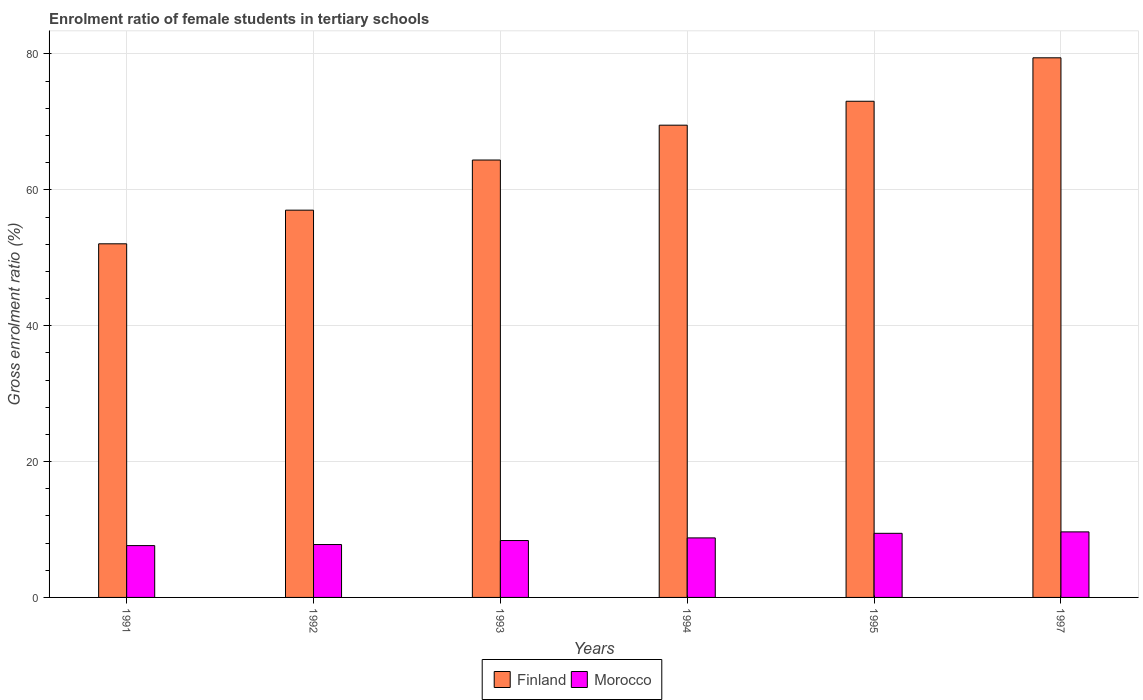How many groups of bars are there?
Give a very brief answer. 6. Are the number of bars per tick equal to the number of legend labels?
Keep it short and to the point. Yes. How many bars are there on the 3rd tick from the left?
Give a very brief answer. 2. What is the label of the 1st group of bars from the left?
Your answer should be compact. 1991. In how many cases, is the number of bars for a given year not equal to the number of legend labels?
Provide a succinct answer. 0. What is the enrolment ratio of female students in tertiary schools in Finland in 1994?
Make the answer very short. 69.52. Across all years, what is the maximum enrolment ratio of female students in tertiary schools in Finland?
Ensure brevity in your answer.  79.43. Across all years, what is the minimum enrolment ratio of female students in tertiary schools in Finland?
Offer a very short reply. 52.05. What is the total enrolment ratio of female students in tertiary schools in Morocco in the graph?
Make the answer very short. 51.64. What is the difference between the enrolment ratio of female students in tertiary schools in Finland in 1992 and that in 1995?
Your answer should be very brief. -16.03. What is the difference between the enrolment ratio of female students in tertiary schools in Finland in 1993 and the enrolment ratio of female students in tertiary schools in Morocco in 1995?
Make the answer very short. 54.95. What is the average enrolment ratio of female students in tertiary schools in Morocco per year?
Give a very brief answer. 8.61. In the year 1994, what is the difference between the enrolment ratio of female students in tertiary schools in Finland and enrolment ratio of female students in tertiary schools in Morocco?
Give a very brief answer. 60.75. What is the ratio of the enrolment ratio of female students in tertiary schools in Morocco in 1994 to that in 1997?
Keep it short and to the point. 0.91. Is the enrolment ratio of female students in tertiary schools in Finland in 1992 less than that in 1994?
Provide a short and direct response. Yes. What is the difference between the highest and the second highest enrolment ratio of female students in tertiary schools in Morocco?
Offer a very short reply. 0.21. What is the difference between the highest and the lowest enrolment ratio of female students in tertiary schools in Morocco?
Give a very brief answer. 2.02. Is the sum of the enrolment ratio of female students in tertiary schools in Finland in 1991 and 1993 greater than the maximum enrolment ratio of female students in tertiary schools in Morocco across all years?
Keep it short and to the point. Yes. What does the 1st bar from the left in 1995 represents?
Your response must be concise. Finland. What does the 1st bar from the right in 1993 represents?
Your response must be concise. Morocco. Are all the bars in the graph horizontal?
Keep it short and to the point. No. What is the difference between two consecutive major ticks on the Y-axis?
Offer a very short reply. 20. Does the graph contain any zero values?
Give a very brief answer. No. Does the graph contain grids?
Make the answer very short. Yes. How are the legend labels stacked?
Provide a short and direct response. Horizontal. What is the title of the graph?
Your response must be concise. Enrolment ratio of female students in tertiary schools. Does "World" appear as one of the legend labels in the graph?
Your answer should be compact. No. What is the Gross enrolment ratio (%) of Finland in 1991?
Your answer should be very brief. 52.05. What is the Gross enrolment ratio (%) of Morocco in 1991?
Your answer should be compact. 7.63. What is the Gross enrolment ratio (%) of Finland in 1992?
Provide a succinct answer. 57.01. What is the Gross enrolment ratio (%) of Morocco in 1992?
Offer a terse response. 7.79. What is the Gross enrolment ratio (%) of Finland in 1993?
Ensure brevity in your answer.  64.39. What is the Gross enrolment ratio (%) in Morocco in 1993?
Offer a very short reply. 8.38. What is the Gross enrolment ratio (%) in Finland in 1994?
Keep it short and to the point. 69.52. What is the Gross enrolment ratio (%) of Morocco in 1994?
Keep it short and to the point. 8.76. What is the Gross enrolment ratio (%) of Finland in 1995?
Your answer should be very brief. 73.04. What is the Gross enrolment ratio (%) in Morocco in 1995?
Your answer should be very brief. 9.44. What is the Gross enrolment ratio (%) in Finland in 1997?
Provide a succinct answer. 79.43. What is the Gross enrolment ratio (%) of Morocco in 1997?
Provide a succinct answer. 9.65. Across all years, what is the maximum Gross enrolment ratio (%) of Finland?
Your response must be concise. 79.43. Across all years, what is the maximum Gross enrolment ratio (%) of Morocco?
Offer a terse response. 9.65. Across all years, what is the minimum Gross enrolment ratio (%) of Finland?
Offer a terse response. 52.05. Across all years, what is the minimum Gross enrolment ratio (%) in Morocco?
Give a very brief answer. 7.63. What is the total Gross enrolment ratio (%) in Finland in the graph?
Make the answer very short. 395.44. What is the total Gross enrolment ratio (%) in Morocco in the graph?
Offer a very short reply. 51.64. What is the difference between the Gross enrolment ratio (%) of Finland in 1991 and that in 1992?
Keep it short and to the point. -4.95. What is the difference between the Gross enrolment ratio (%) in Morocco in 1991 and that in 1992?
Ensure brevity in your answer.  -0.16. What is the difference between the Gross enrolment ratio (%) in Finland in 1991 and that in 1993?
Ensure brevity in your answer.  -12.33. What is the difference between the Gross enrolment ratio (%) in Morocco in 1991 and that in 1993?
Your response must be concise. -0.75. What is the difference between the Gross enrolment ratio (%) in Finland in 1991 and that in 1994?
Ensure brevity in your answer.  -17.46. What is the difference between the Gross enrolment ratio (%) in Morocco in 1991 and that in 1994?
Give a very brief answer. -1.13. What is the difference between the Gross enrolment ratio (%) of Finland in 1991 and that in 1995?
Provide a short and direct response. -20.99. What is the difference between the Gross enrolment ratio (%) in Morocco in 1991 and that in 1995?
Provide a succinct answer. -1.81. What is the difference between the Gross enrolment ratio (%) of Finland in 1991 and that in 1997?
Offer a terse response. -27.38. What is the difference between the Gross enrolment ratio (%) of Morocco in 1991 and that in 1997?
Make the answer very short. -2.02. What is the difference between the Gross enrolment ratio (%) of Finland in 1992 and that in 1993?
Your response must be concise. -7.38. What is the difference between the Gross enrolment ratio (%) in Morocco in 1992 and that in 1993?
Make the answer very short. -0.59. What is the difference between the Gross enrolment ratio (%) in Finland in 1992 and that in 1994?
Your answer should be very brief. -12.51. What is the difference between the Gross enrolment ratio (%) of Morocco in 1992 and that in 1994?
Offer a terse response. -0.98. What is the difference between the Gross enrolment ratio (%) of Finland in 1992 and that in 1995?
Your answer should be compact. -16.03. What is the difference between the Gross enrolment ratio (%) in Morocco in 1992 and that in 1995?
Offer a very short reply. -1.65. What is the difference between the Gross enrolment ratio (%) of Finland in 1992 and that in 1997?
Provide a succinct answer. -22.43. What is the difference between the Gross enrolment ratio (%) in Morocco in 1992 and that in 1997?
Offer a terse response. -1.86. What is the difference between the Gross enrolment ratio (%) of Finland in 1993 and that in 1994?
Your response must be concise. -5.13. What is the difference between the Gross enrolment ratio (%) of Morocco in 1993 and that in 1994?
Your answer should be very brief. -0.39. What is the difference between the Gross enrolment ratio (%) in Finland in 1993 and that in 1995?
Make the answer very short. -8.65. What is the difference between the Gross enrolment ratio (%) in Morocco in 1993 and that in 1995?
Offer a very short reply. -1.06. What is the difference between the Gross enrolment ratio (%) in Finland in 1993 and that in 1997?
Offer a very short reply. -15.05. What is the difference between the Gross enrolment ratio (%) of Morocco in 1993 and that in 1997?
Your answer should be very brief. -1.27. What is the difference between the Gross enrolment ratio (%) in Finland in 1994 and that in 1995?
Keep it short and to the point. -3.52. What is the difference between the Gross enrolment ratio (%) of Morocco in 1994 and that in 1995?
Offer a terse response. -0.67. What is the difference between the Gross enrolment ratio (%) in Finland in 1994 and that in 1997?
Keep it short and to the point. -9.92. What is the difference between the Gross enrolment ratio (%) of Morocco in 1994 and that in 1997?
Provide a succinct answer. -0.88. What is the difference between the Gross enrolment ratio (%) of Finland in 1995 and that in 1997?
Offer a very short reply. -6.4. What is the difference between the Gross enrolment ratio (%) in Morocco in 1995 and that in 1997?
Offer a terse response. -0.21. What is the difference between the Gross enrolment ratio (%) in Finland in 1991 and the Gross enrolment ratio (%) in Morocco in 1992?
Provide a succinct answer. 44.27. What is the difference between the Gross enrolment ratio (%) in Finland in 1991 and the Gross enrolment ratio (%) in Morocco in 1993?
Your answer should be compact. 43.68. What is the difference between the Gross enrolment ratio (%) in Finland in 1991 and the Gross enrolment ratio (%) in Morocco in 1994?
Give a very brief answer. 43.29. What is the difference between the Gross enrolment ratio (%) of Finland in 1991 and the Gross enrolment ratio (%) of Morocco in 1995?
Your answer should be very brief. 42.62. What is the difference between the Gross enrolment ratio (%) in Finland in 1991 and the Gross enrolment ratio (%) in Morocco in 1997?
Your answer should be compact. 42.41. What is the difference between the Gross enrolment ratio (%) of Finland in 1992 and the Gross enrolment ratio (%) of Morocco in 1993?
Ensure brevity in your answer.  48.63. What is the difference between the Gross enrolment ratio (%) in Finland in 1992 and the Gross enrolment ratio (%) in Morocco in 1994?
Provide a short and direct response. 48.24. What is the difference between the Gross enrolment ratio (%) in Finland in 1992 and the Gross enrolment ratio (%) in Morocco in 1995?
Make the answer very short. 47.57. What is the difference between the Gross enrolment ratio (%) in Finland in 1992 and the Gross enrolment ratio (%) in Morocco in 1997?
Make the answer very short. 47.36. What is the difference between the Gross enrolment ratio (%) of Finland in 1993 and the Gross enrolment ratio (%) of Morocco in 1994?
Offer a terse response. 55.62. What is the difference between the Gross enrolment ratio (%) in Finland in 1993 and the Gross enrolment ratio (%) in Morocco in 1995?
Your answer should be very brief. 54.95. What is the difference between the Gross enrolment ratio (%) in Finland in 1993 and the Gross enrolment ratio (%) in Morocco in 1997?
Make the answer very short. 54.74. What is the difference between the Gross enrolment ratio (%) of Finland in 1994 and the Gross enrolment ratio (%) of Morocco in 1995?
Make the answer very short. 60.08. What is the difference between the Gross enrolment ratio (%) in Finland in 1994 and the Gross enrolment ratio (%) in Morocco in 1997?
Offer a terse response. 59.87. What is the difference between the Gross enrolment ratio (%) of Finland in 1995 and the Gross enrolment ratio (%) of Morocco in 1997?
Make the answer very short. 63.39. What is the average Gross enrolment ratio (%) of Finland per year?
Make the answer very short. 65.91. What is the average Gross enrolment ratio (%) in Morocco per year?
Provide a short and direct response. 8.61. In the year 1991, what is the difference between the Gross enrolment ratio (%) in Finland and Gross enrolment ratio (%) in Morocco?
Offer a very short reply. 44.42. In the year 1992, what is the difference between the Gross enrolment ratio (%) in Finland and Gross enrolment ratio (%) in Morocco?
Offer a terse response. 49.22. In the year 1993, what is the difference between the Gross enrolment ratio (%) in Finland and Gross enrolment ratio (%) in Morocco?
Provide a succinct answer. 56.01. In the year 1994, what is the difference between the Gross enrolment ratio (%) of Finland and Gross enrolment ratio (%) of Morocco?
Give a very brief answer. 60.75. In the year 1995, what is the difference between the Gross enrolment ratio (%) of Finland and Gross enrolment ratio (%) of Morocco?
Ensure brevity in your answer.  63.6. In the year 1997, what is the difference between the Gross enrolment ratio (%) in Finland and Gross enrolment ratio (%) in Morocco?
Make the answer very short. 69.79. What is the ratio of the Gross enrolment ratio (%) in Finland in 1991 to that in 1992?
Provide a succinct answer. 0.91. What is the ratio of the Gross enrolment ratio (%) of Morocco in 1991 to that in 1992?
Your answer should be compact. 0.98. What is the ratio of the Gross enrolment ratio (%) in Finland in 1991 to that in 1993?
Keep it short and to the point. 0.81. What is the ratio of the Gross enrolment ratio (%) of Morocco in 1991 to that in 1993?
Keep it short and to the point. 0.91. What is the ratio of the Gross enrolment ratio (%) of Finland in 1991 to that in 1994?
Give a very brief answer. 0.75. What is the ratio of the Gross enrolment ratio (%) in Morocco in 1991 to that in 1994?
Your answer should be compact. 0.87. What is the ratio of the Gross enrolment ratio (%) of Finland in 1991 to that in 1995?
Your answer should be very brief. 0.71. What is the ratio of the Gross enrolment ratio (%) of Morocco in 1991 to that in 1995?
Ensure brevity in your answer.  0.81. What is the ratio of the Gross enrolment ratio (%) in Finland in 1991 to that in 1997?
Your answer should be very brief. 0.66. What is the ratio of the Gross enrolment ratio (%) of Morocco in 1991 to that in 1997?
Your answer should be compact. 0.79. What is the ratio of the Gross enrolment ratio (%) of Finland in 1992 to that in 1993?
Provide a succinct answer. 0.89. What is the ratio of the Gross enrolment ratio (%) in Morocco in 1992 to that in 1993?
Ensure brevity in your answer.  0.93. What is the ratio of the Gross enrolment ratio (%) in Finland in 1992 to that in 1994?
Ensure brevity in your answer.  0.82. What is the ratio of the Gross enrolment ratio (%) in Morocco in 1992 to that in 1994?
Your answer should be compact. 0.89. What is the ratio of the Gross enrolment ratio (%) in Finland in 1992 to that in 1995?
Ensure brevity in your answer.  0.78. What is the ratio of the Gross enrolment ratio (%) of Morocco in 1992 to that in 1995?
Offer a terse response. 0.83. What is the ratio of the Gross enrolment ratio (%) in Finland in 1992 to that in 1997?
Your answer should be compact. 0.72. What is the ratio of the Gross enrolment ratio (%) in Morocco in 1992 to that in 1997?
Offer a terse response. 0.81. What is the ratio of the Gross enrolment ratio (%) of Finland in 1993 to that in 1994?
Offer a terse response. 0.93. What is the ratio of the Gross enrolment ratio (%) of Morocco in 1993 to that in 1994?
Your answer should be compact. 0.96. What is the ratio of the Gross enrolment ratio (%) of Finland in 1993 to that in 1995?
Offer a terse response. 0.88. What is the ratio of the Gross enrolment ratio (%) of Morocco in 1993 to that in 1995?
Offer a terse response. 0.89. What is the ratio of the Gross enrolment ratio (%) of Finland in 1993 to that in 1997?
Offer a terse response. 0.81. What is the ratio of the Gross enrolment ratio (%) of Morocco in 1993 to that in 1997?
Provide a succinct answer. 0.87. What is the ratio of the Gross enrolment ratio (%) in Finland in 1994 to that in 1995?
Give a very brief answer. 0.95. What is the ratio of the Gross enrolment ratio (%) of Morocco in 1994 to that in 1995?
Provide a short and direct response. 0.93. What is the ratio of the Gross enrolment ratio (%) in Finland in 1994 to that in 1997?
Your response must be concise. 0.88. What is the ratio of the Gross enrolment ratio (%) in Morocco in 1994 to that in 1997?
Make the answer very short. 0.91. What is the ratio of the Gross enrolment ratio (%) of Finland in 1995 to that in 1997?
Ensure brevity in your answer.  0.92. What is the ratio of the Gross enrolment ratio (%) of Morocco in 1995 to that in 1997?
Give a very brief answer. 0.98. What is the difference between the highest and the second highest Gross enrolment ratio (%) in Finland?
Your response must be concise. 6.4. What is the difference between the highest and the second highest Gross enrolment ratio (%) in Morocco?
Give a very brief answer. 0.21. What is the difference between the highest and the lowest Gross enrolment ratio (%) of Finland?
Provide a short and direct response. 27.38. What is the difference between the highest and the lowest Gross enrolment ratio (%) of Morocco?
Provide a succinct answer. 2.02. 